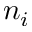<formula> <loc_0><loc_0><loc_500><loc_500>n _ { i }</formula> 